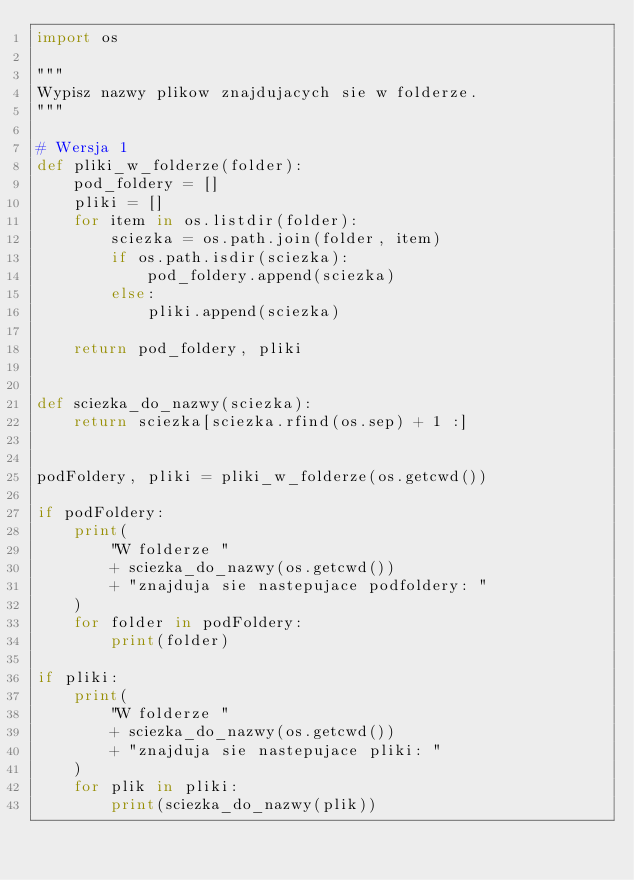Convert code to text. <code><loc_0><loc_0><loc_500><loc_500><_Python_>import os

"""
Wypisz nazwy plikow znajdujacych sie w folderze.
"""

# Wersja 1
def pliki_w_folderze(folder):
    pod_foldery = []
    pliki = []
    for item in os.listdir(folder):
        sciezka = os.path.join(folder, item)
        if os.path.isdir(sciezka):
            pod_foldery.append(sciezka)
        else:
            pliki.append(sciezka)

    return pod_foldery, pliki


def sciezka_do_nazwy(sciezka):
    return sciezka[sciezka.rfind(os.sep) + 1 :]


podFoldery, pliki = pliki_w_folderze(os.getcwd())

if podFoldery:
    print(
        "W folderze "
        + sciezka_do_nazwy(os.getcwd())
        + "znajduja sie nastepujace podfoldery: "
    )
    for folder in podFoldery:
        print(folder)

if pliki:
    print(
        "W folderze "
        + sciezka_do_nazwy(os.getcwd())
        + "znajduja sie nastepujace pliki: "
    )
    for plik in pliki:
        print(sciezka_do_nazwy(plik))
</code> 